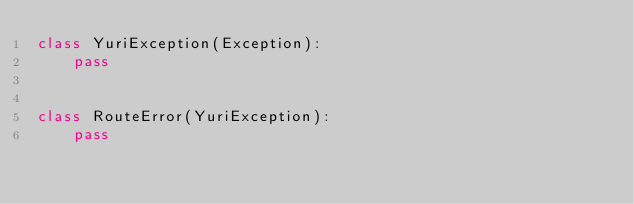Convert code to text. <code><loc_0><loc_0><loc_500><loc_500><_Python_>class YuriException(Exception):
    pass


class RouteError(YuriException):
    pass
</code> 